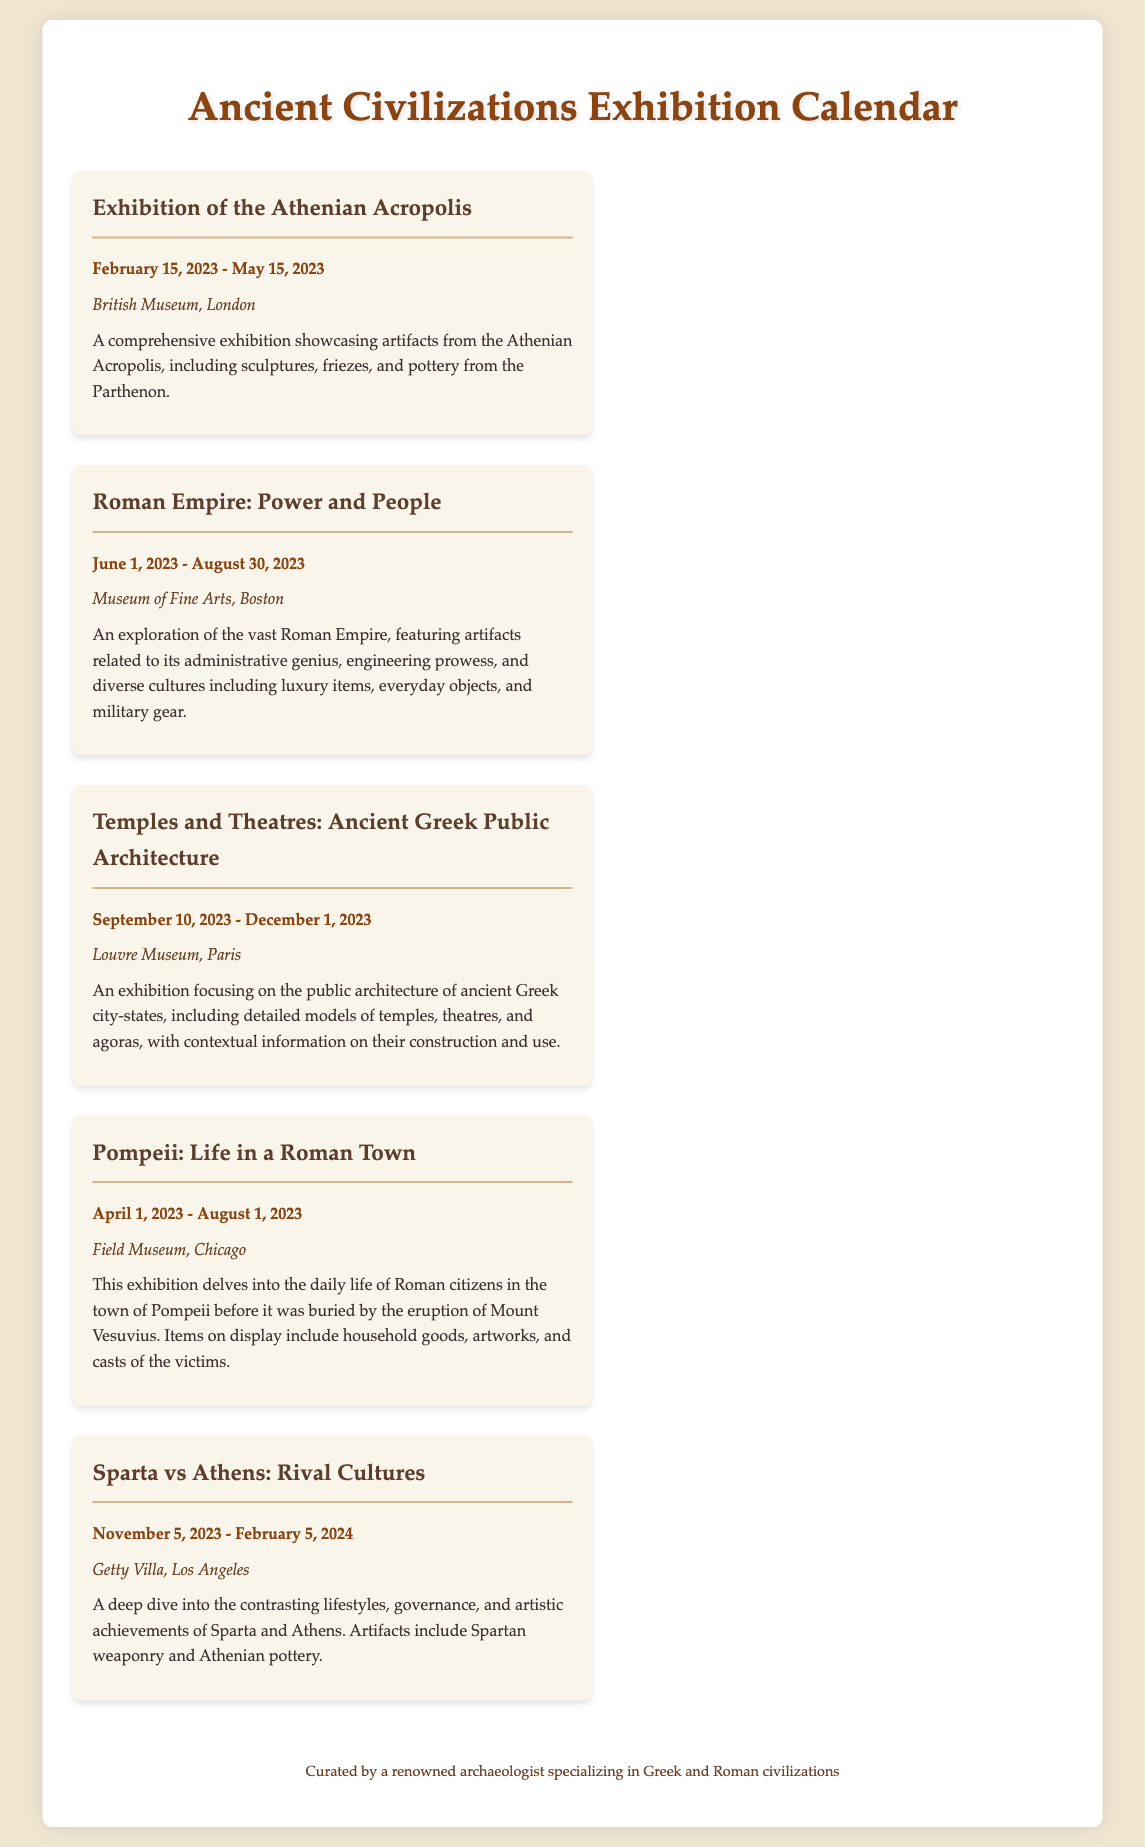What is the title of the exhibition showcasing artifacts from the Athenian Acropolis? The title of the exhibition is explicitly stated as "Exhibition of the Athenian Acropolis."
Answer: Exhibition of the Athenian Acropolis When does the "Roman Empire: Power and People" exhibition start? The starting date for the "Roman Empire: Power and People" exhibition is highlighted as June 1, 2023.
Answer: June 1, 2023 Which museum is hosting the "Temples and Theatres: Ancient Greek Public Architecture" exhibition? The museum mentioned for this exhibition is the Louvre Museum in Paris.
Answer: Louvre Museum, Paris What artifacts are included in the "Sparta vs Athens: Rival Cultures" exhibition? The document states that artifacts include "Spartan weaponry and Athenian pottery."
Answer: Spartan weaponry and Athenian pottery What is the end date of the "Pompeii: Life in a Roman Town" exhibition? The end date for the "Pompeii: Life in a Roman Town" exhibition is detailed as August 1, 2023.
Answer: August 1, 2023 How long does the "Temples and Theatres" exhibition run? The duration is from September 10, 2023, to December 1, 2023, which is approximately 80 days.
Answer: Approximately 80 days Which city is the "Sparta vs Athens: Rival Cultures" exhibition located? The city where this exhibition is held is specified as Los Angeles.
Answer: Los Angeles What type of artifacts are featured in the "Pompeii" exhibition? The document describes the artifacts as including "household goods, artworks, and casts of the victims."
Answer: Household goods, artworks, and casts of the victims 